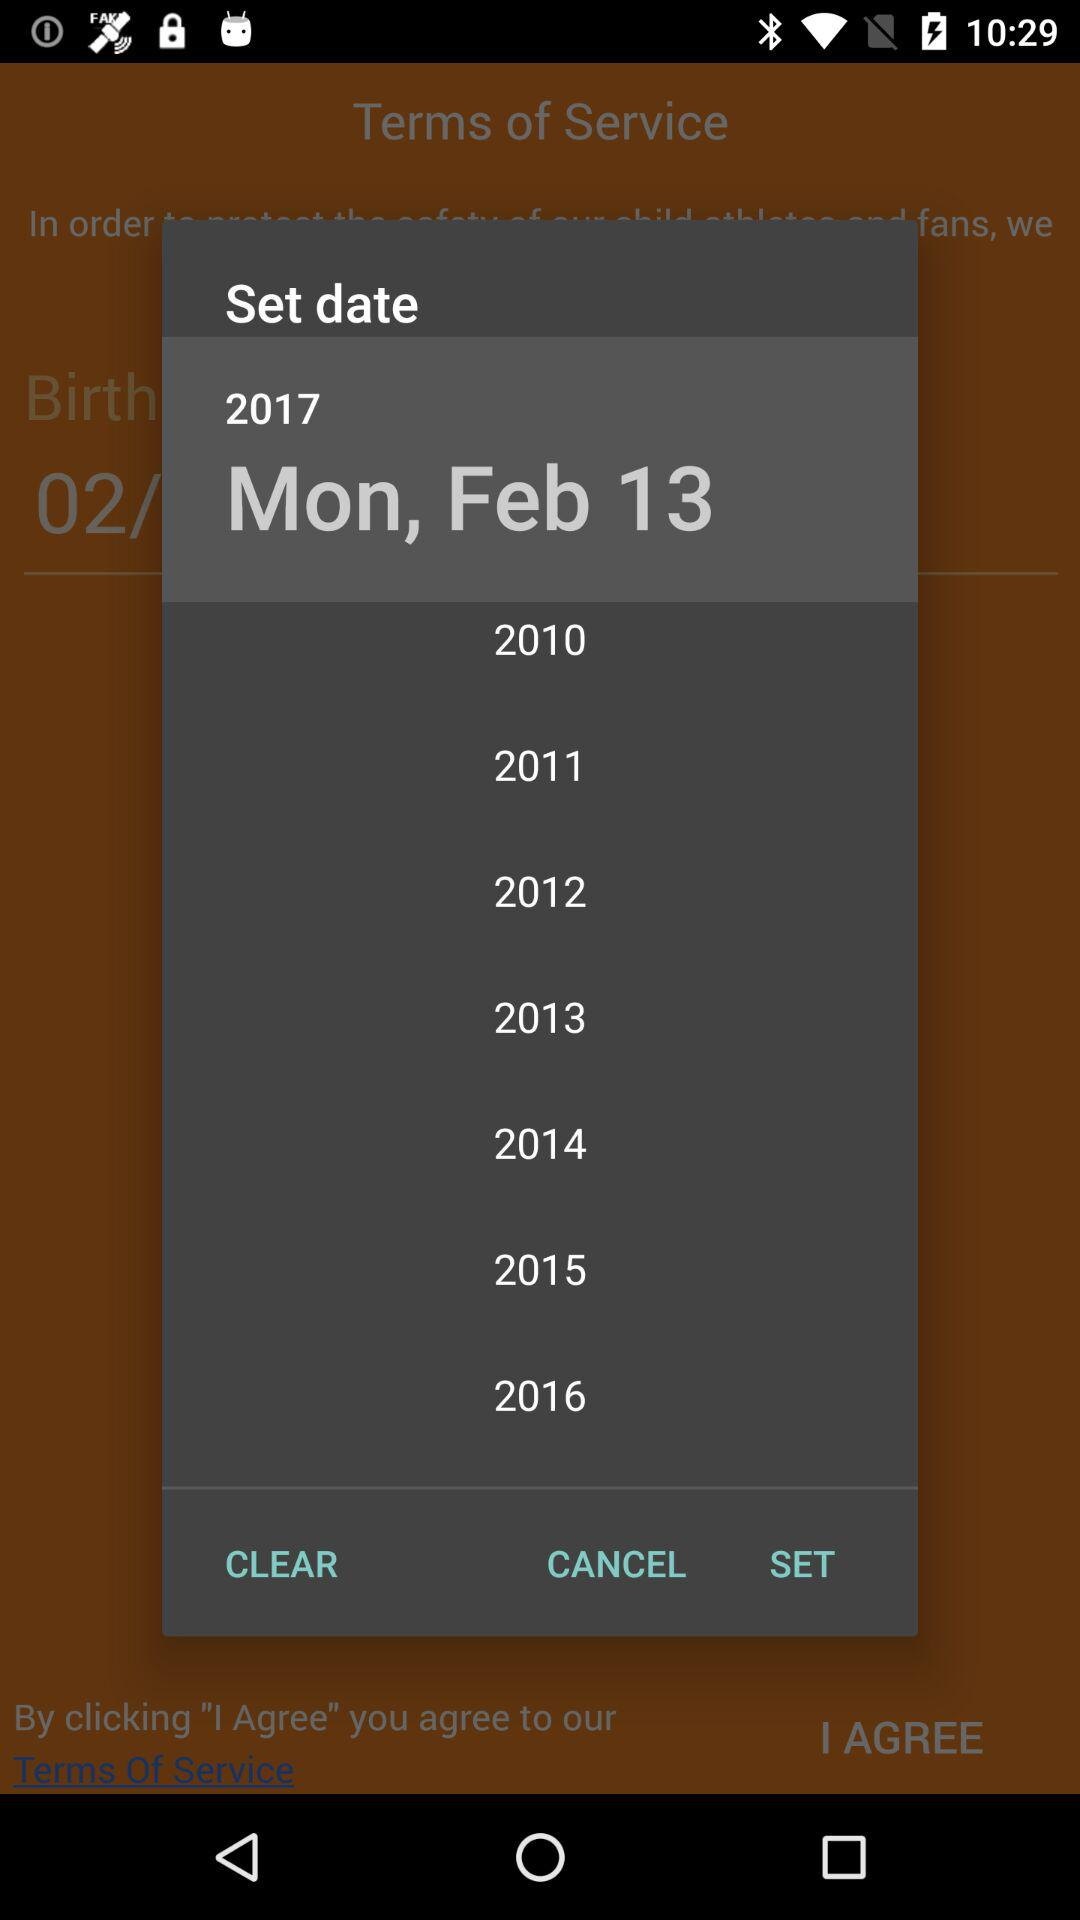Which day falls on February 13? The day that falls on February 13 is Monday. 